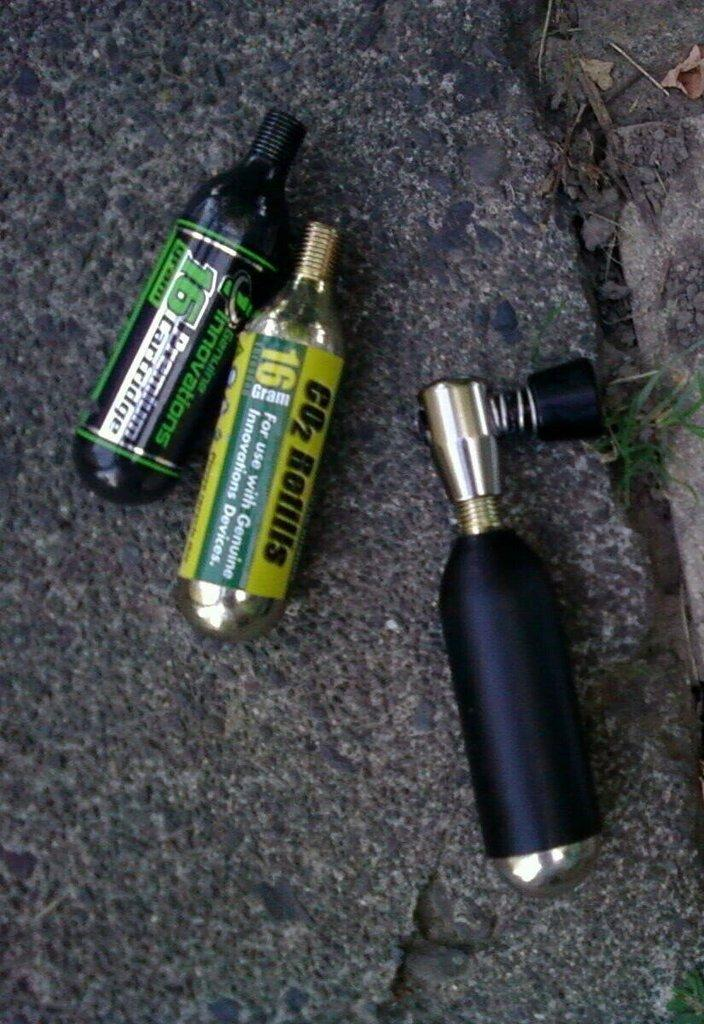What objects are on the ground in the image? There are bottles on the ground in the image. What type of flower is growing in the bottle in the image? There are no flowers present in the image; it only shows bottles on the ground. 